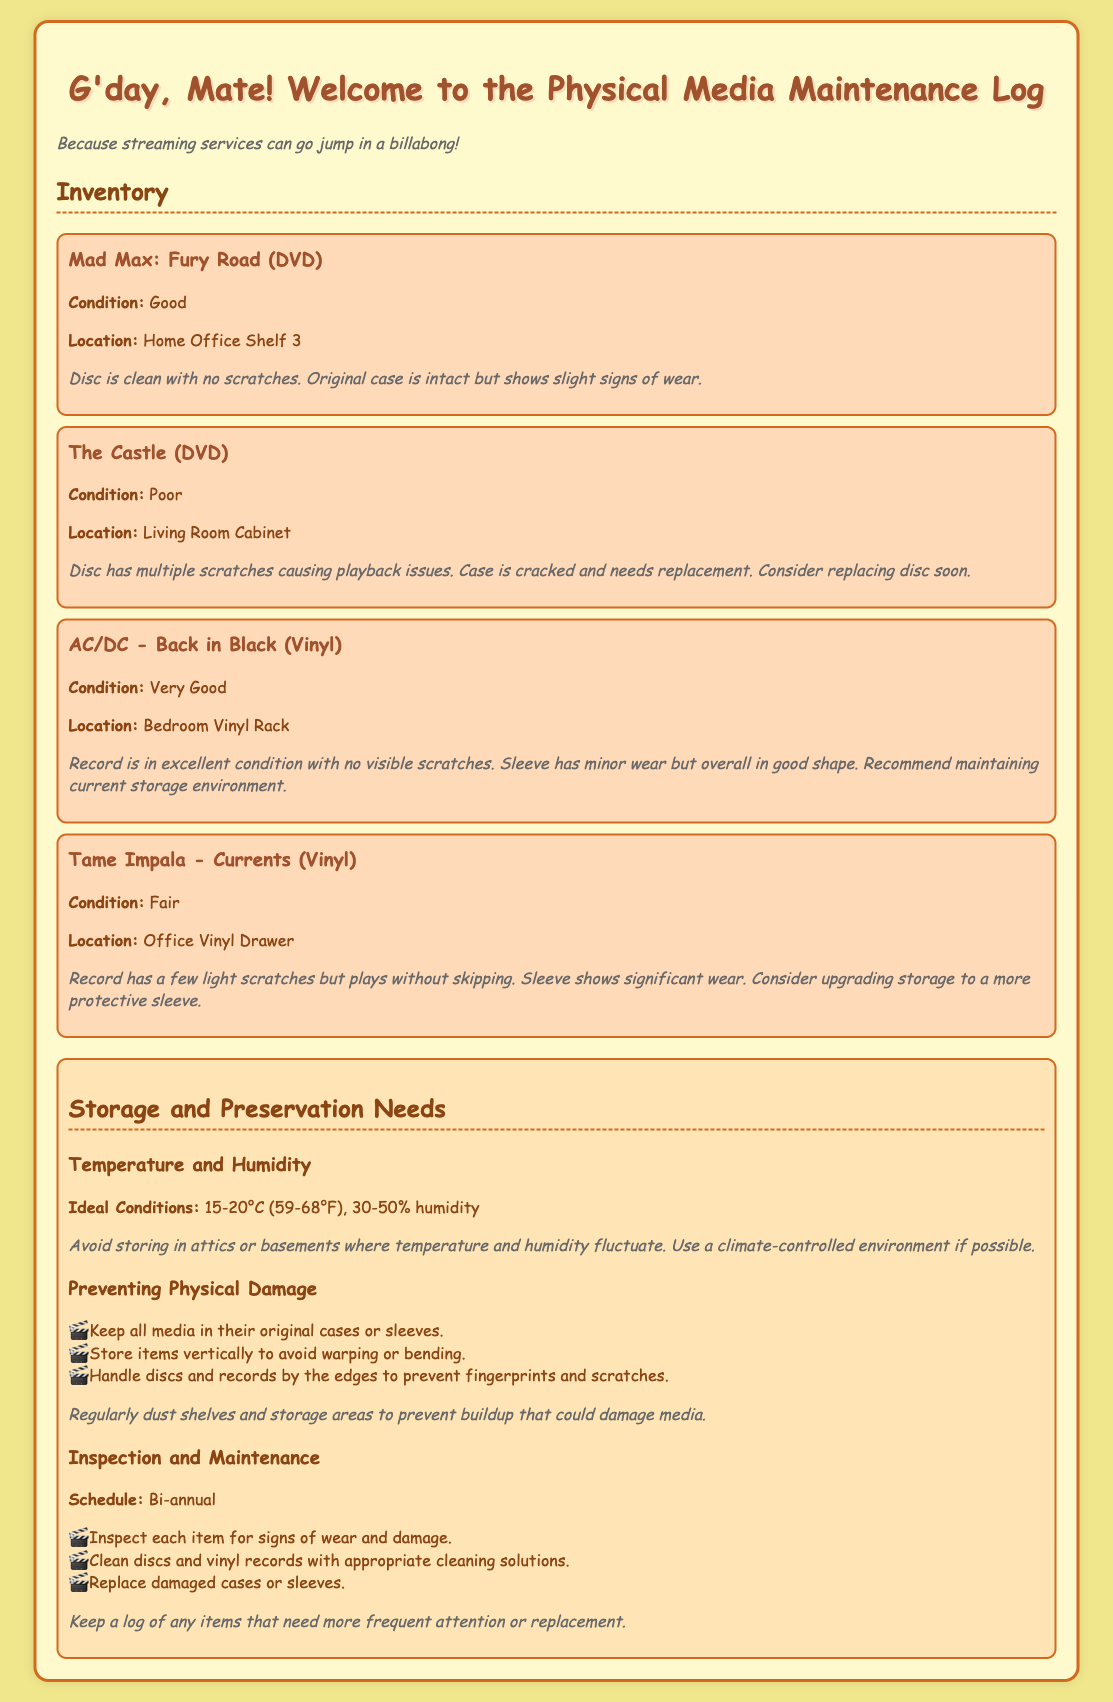What is the condition of "The Castle" DVD? The condition of "The Castle" DVD is listed in the inventory section, stating it is "Poor."
Answer: Poor Where is "Mad Max: Fury Road" located? The inventory specifies that "Mad Max: Fury Road" is located on "Home Office Shelf 3."
Answer: Home Office Shelf 3 How many light scratches does "Tame Impala - Currents" have? The document notes that "Tame Impala - Currents" has "a few light scratches."
Answer: A few What is the ideal humidity range for storage? The document provides the ideal conditions for humidity as "30-50% humidity."
Answer: 30-50% humidity What is recommended to prevent physical damage to media? A list in the preservation needs section includes specific actions, one being "Keep all media in their original cases."
Answer: Keep all media in their original cases What is the frequency of the inspection and maintenance schedule? The maintenance log states that inspections should occur "Bi-annual."
Answer: Bi-annual What does the sleeve of "AC/DC - Back in Black" have? The inventory mentions that the sleeve of "AC/DC - Back in Black" has "minor wear."
Answer: Minor wear What needs to be considered for the storage environment? The notes advise using a "climate-controlled environment if possible."
Answer: Climate-controlled environment What should be done for damaged cases or sleeves? The inspection and maintenance section notes to "Replace damaged cases or sleeves."
Answer: Replace damaged cases or sleeves 